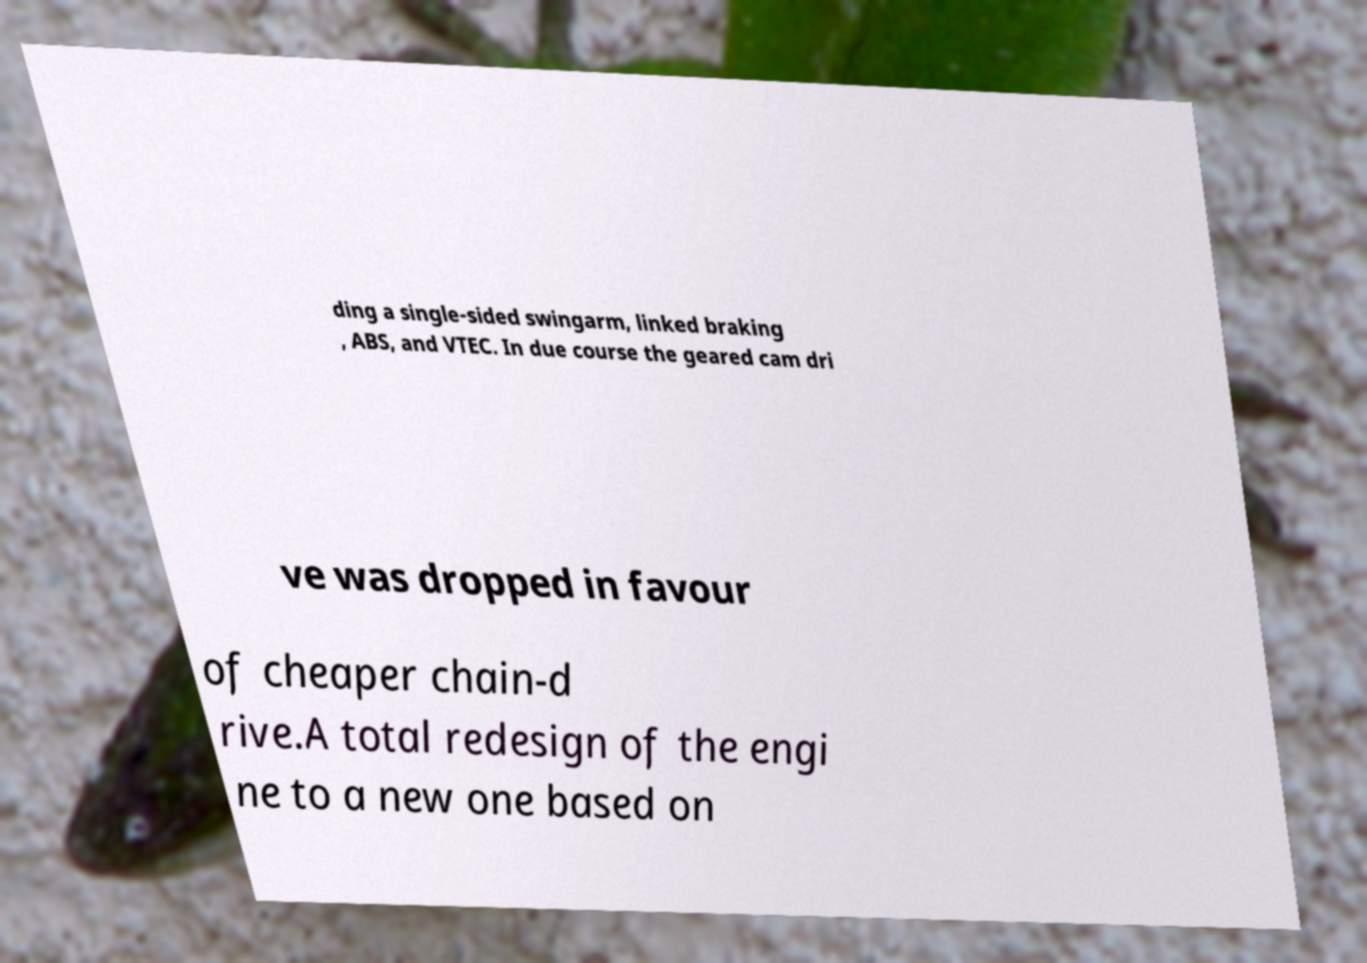There's text embedded in this image that I need extracted. Can you transcribe it verbatim? ding a single-sided swingarm, linked braking , ABS, and VTEC. In due course the geared cam dri ve was dropped in favour of cheaper chain-d rive.A total redesign of the engi ne to a new one based on 